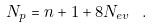<formula> <loc_0><loc_0><loc_500><loc_500>N _ { p } = n + 1 + 8 N _ { e v } \ .</formula> 